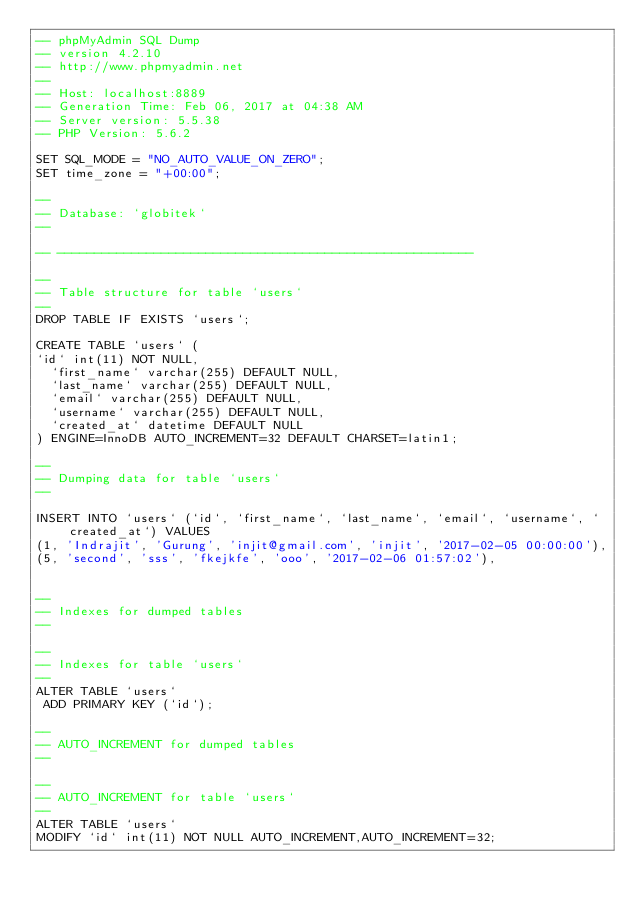Convert code to text. <code><loc_0><loc_0><loc_500><loc_500><_SQL_>-- phpMyAdmin SQL Dump
-- version 4.2.10
-- http://www.phpmyadmin.net
--
-- Host: localhost:8889
-- Generation Time: Feb 06, 2017 at 04:38 AM
-- Server version: 5.5.38
-- PHP Version: 5.6.2

SET SQL_MODE = "NO_AUTO_VALUE_ON_ZERO";
SET time_zone = "+00:00";

--
-- Database: `globitek`
--

-- --------------------------------------------------------

--
-- Table structure for table `users`
--
DROP TABLE IF EXISTS `users`;

CREATE TABLE `users` (
`id` int(11) NOT NULL,
  `first_name` varchar(255) DEFAULT NULL,
  `last_name` varchar(255) DEFAULT NULL,
  `email` varchar(255) DEFAULT NULL,
  `username` varchar(255) DEFAULT NULL,
  `created_at` datetime DEFAULT NULL
) ENGINE=InnoDB AUTO_INCREMENT=32 DEFAULT CHARSET=latin1;

--
-- Dumping data for table `users`
--

INSERT INTO `users` (`id`, `first_name`, `last_name`, `email`, `username`, `created_at`) VALUES
(1, 'Indrajit', 'Gurung', 'injit@gmail.com', 'injit', '2017-02-05 00:00:00'),
(5, 'second', 'sss', 'fkejkfe', 'ooo', '2017-02-06 01:57:02'),


--
-- Indexes for dumped tables
--

--
-- Indexes for table `users`
--
ALTER TABLE `users`
 ADD PRIMARY KEY (`id`);

--
-- AUTO_INCREMENT for dumped tables
--

--
-- AUTO_INCREMENT for table `users`
--
ALTER TABLE `users`
MODIFY `id` int(11) NOT NULL AUTO_INCREMENT,AUTO_INCREMENT=32;
</code> 